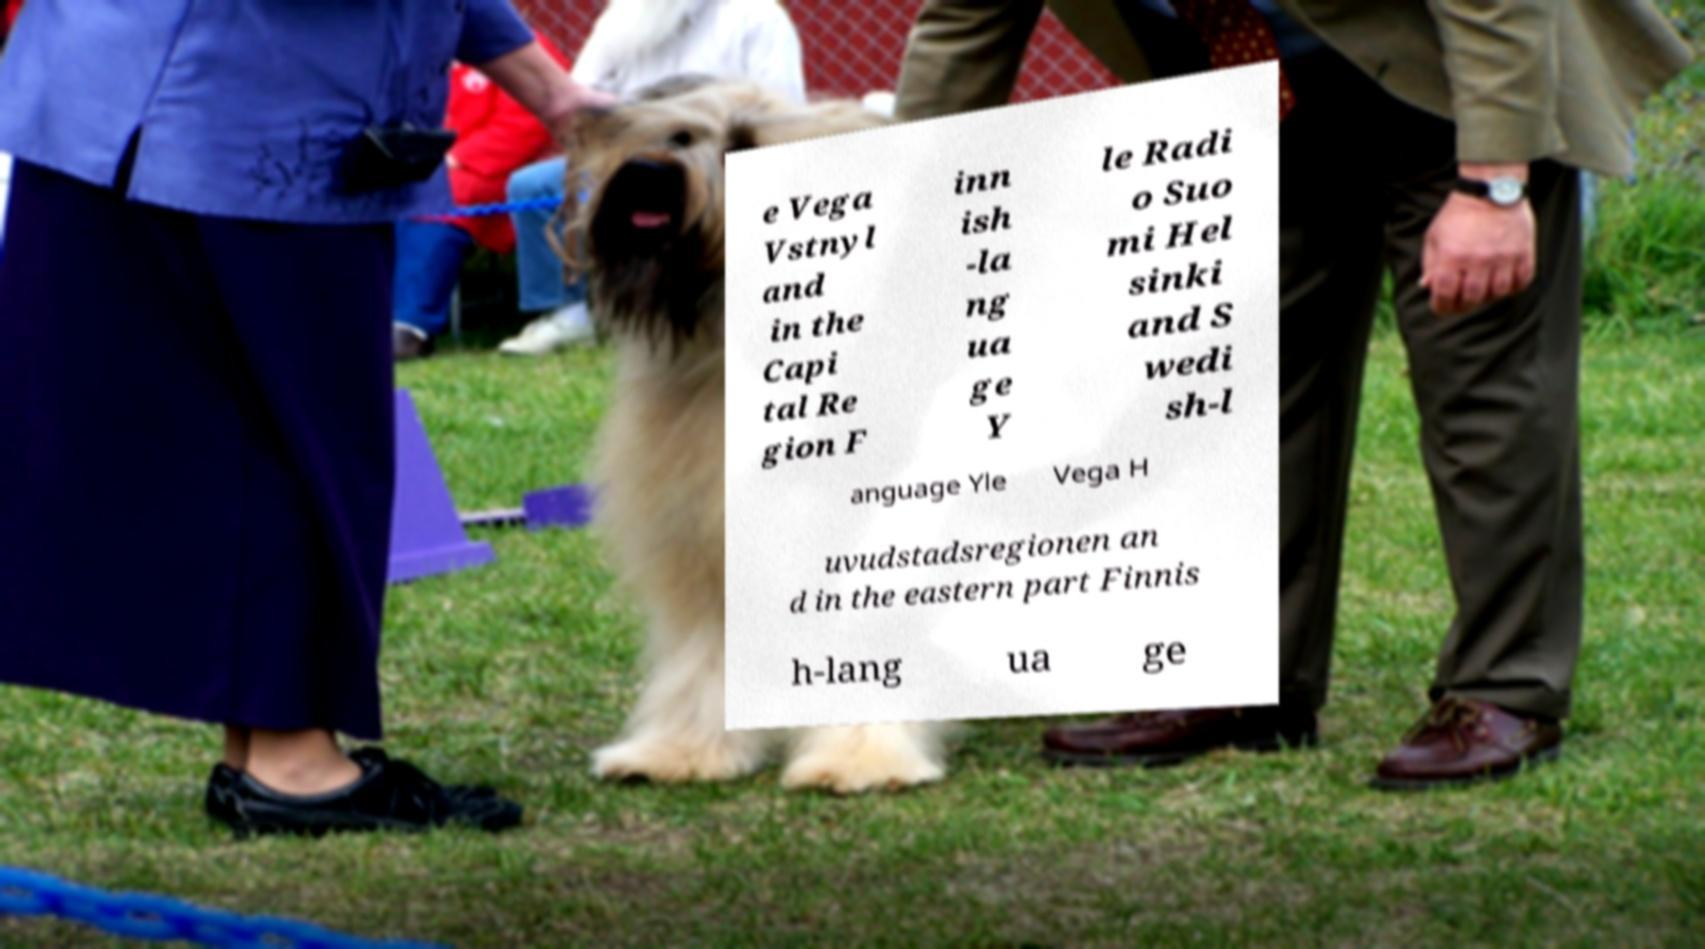Please read and relay the text visible in this image. What does it say? e Vega Vstnyl and in the Capi tal Re gion F inn ish -la ng ua ge Y le Radi o Suo mi Hel sinki and S wedi sh-l anguage Yle Vega H uvudstadsregionen an d in the eastern part Finnis h-lang ua ge 